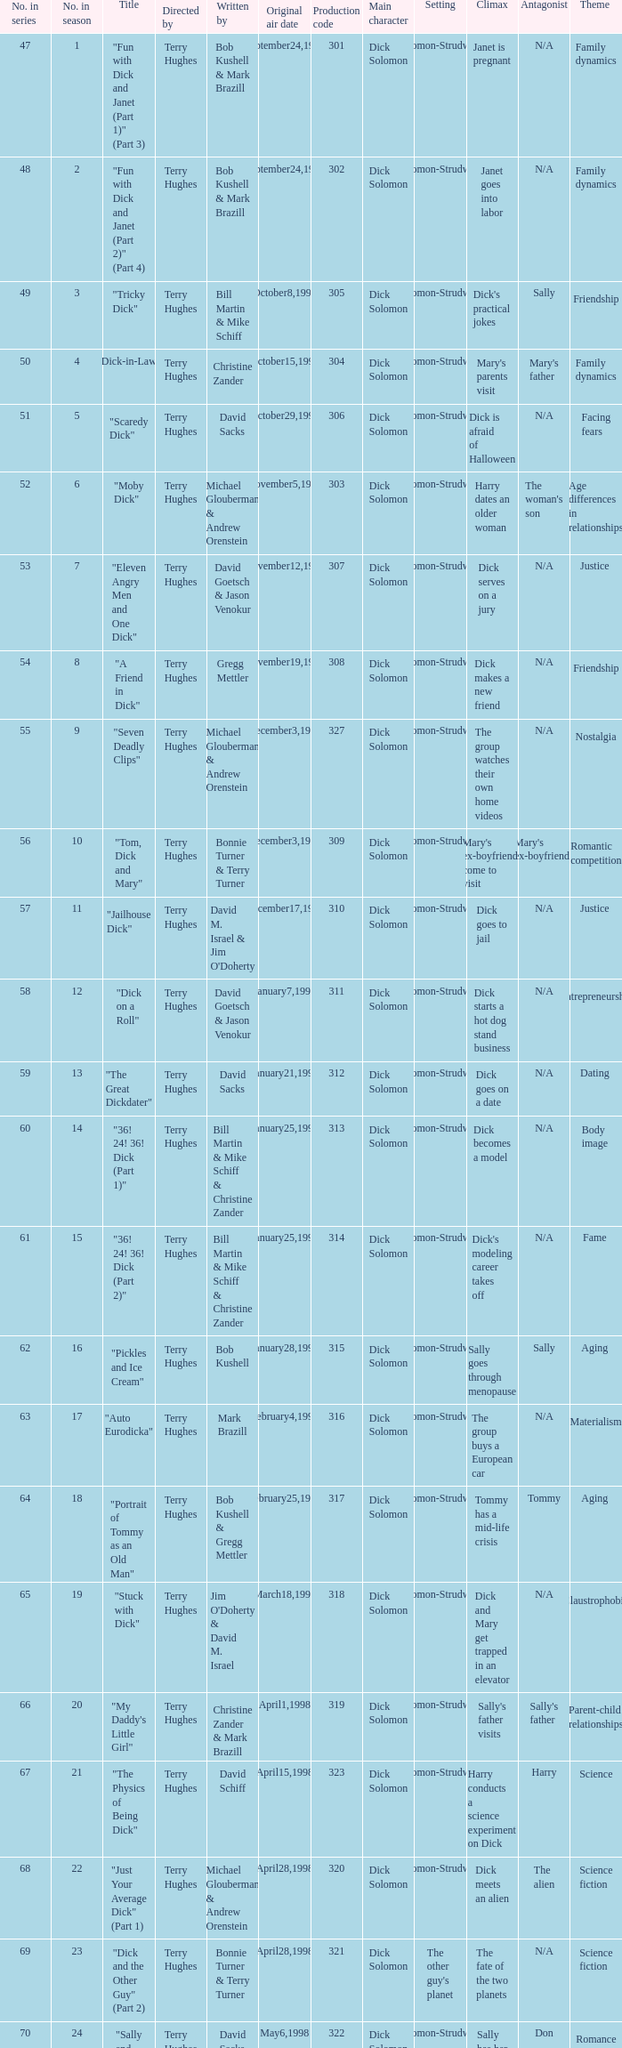Who were the writers of the episode titled "Tricky Dick"? Bill Martin & Mike Schiff. 